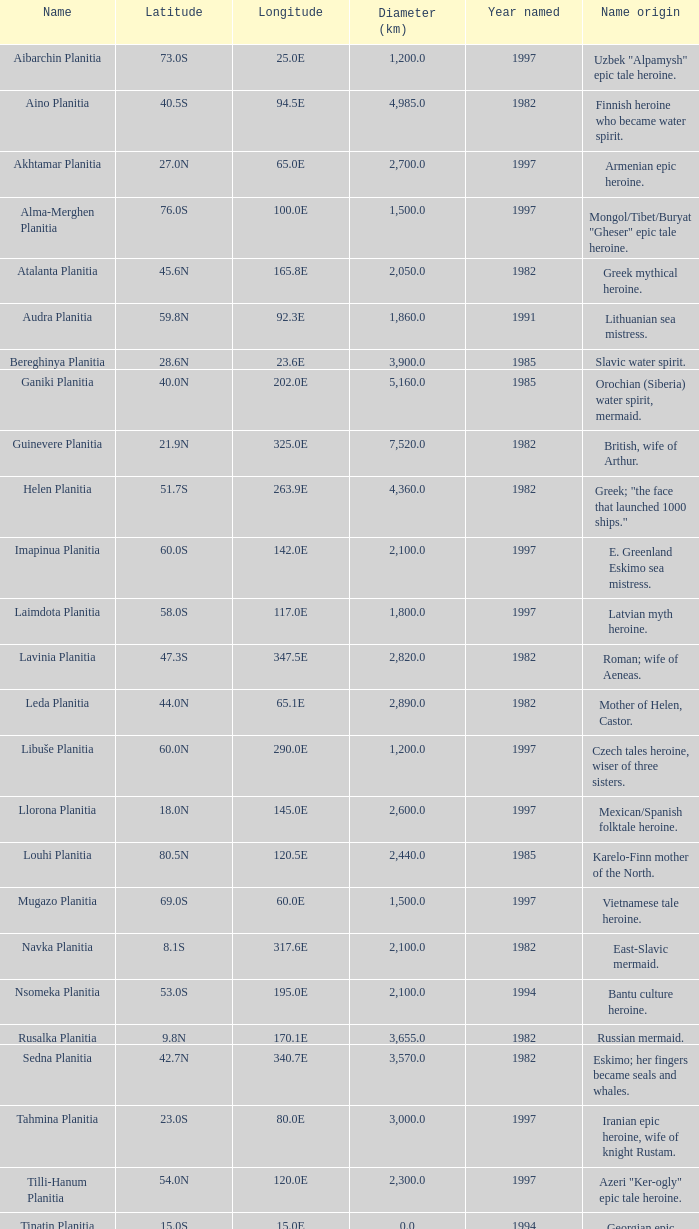0s? 3000.0. 